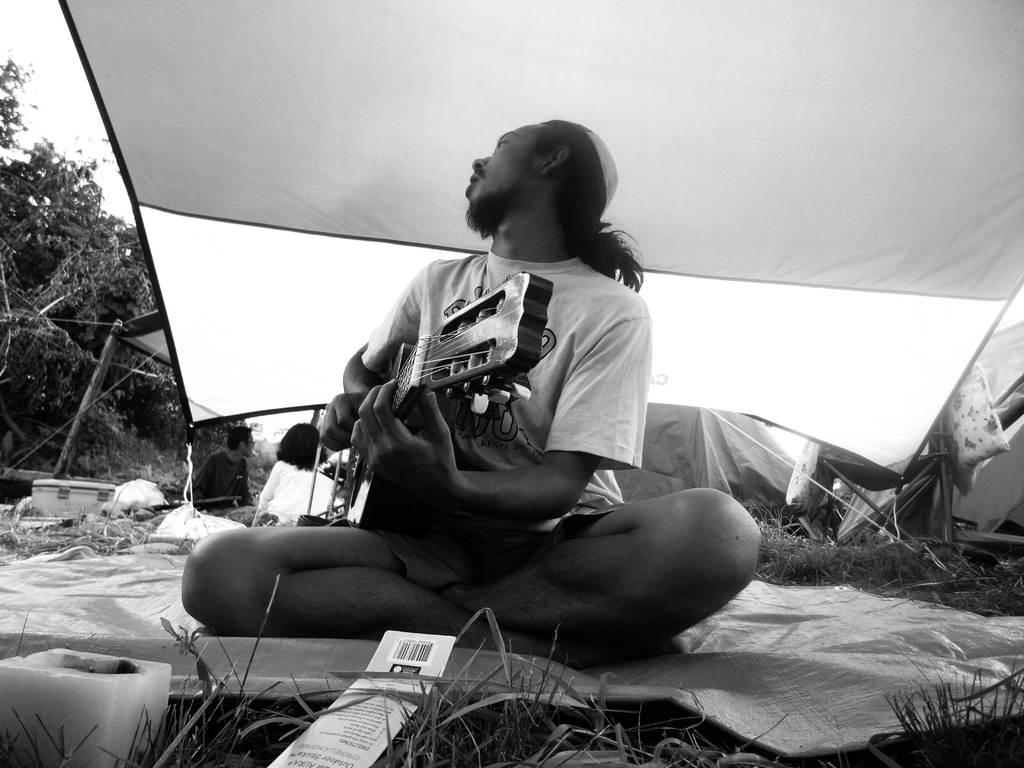What is the main subject of the image? The main subject of the image is a man. What is the man doing in the image? The man is sitting on the grass and playing a guitar. What is the man sitting on? The man is sitting on a cloth. How is the man holding the guitar? The guitar is in his hands. What can be seen in the background of the image? There is a fabric roof, trees, and the sky visible in the background of the image. How many cacti are present in the image? There are no cacti present in the image. What type of bait is the man using to catch fish in the image? There is no fishing or bait present in the image; the man is playing a guitar. 